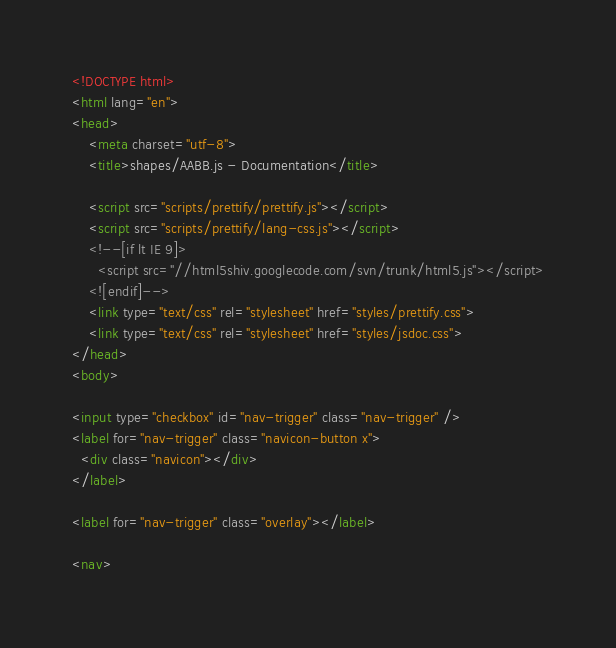<code> <loc_0><loc_0><loc_500><loc_500><_HTML_><!DOCTYPE html>
<html lang="en">
<head>
    <meta charset="utf-8">
    <title>shapes/AABB.js - Documentation</title>

    <script src="scripts/prettify/prettify.js"></script>
    <script src="scripts/prettify/lang-css.js"></script>
    <!--[if lt IE 9]>
      <script src="//html5shiv.googlecode.com/svn/trunk/html5.js"></script>
    <![endif]-->
    <link type="text/css" rel="stylesheet" href="styles/prettify.css">
    <link type="text/css" rel="stylesheet" href="styles/jsdoc.css">
</head>
<body>

<input type="checkbox" id="nav-trigger" class="nav-trigger" />
<label for="nav-trigger" class="navicon-button x">
  <div class="navicon"></div>
</label>

<label for="nav-trigger" class="overlay"></label>

<nav></code> 